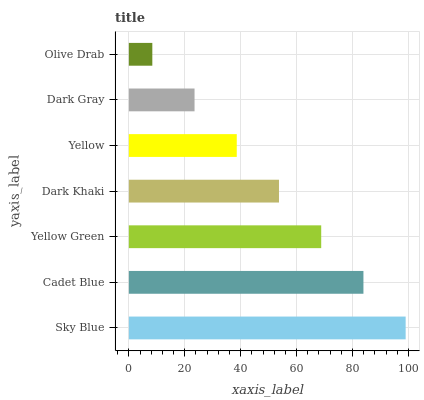Is Olive Drab the minimum?
Answer yes or no. Yes. Is Sky Blue the maximum?
Answer yes or no. Yes. Is Cadet Blue the minimum?
Answer yes or no. No. Is Cadet Blue the maximum?
Answer yes or no. No. Is Sky Blue greater than Cadet Blue?
Answer yes or no. Yes. Is Cadet Blue less than Sky Blue?
Answer yes or no. Yes. Is Cadet Blue greater than Sky Blue?
Answer yes or no. No. Is Sky Blue less than Cadet Blue?
Answer yes or no. No. Is Dark Khaki the high median?
Answer yes or no. Yes. Is Dark Khaki the low median?
Answer yes or no. Yes. Is Sky Blue the high median?
Answer yes or no. No. Is Cadet Blue the low median?
Answer yes or no. No. 